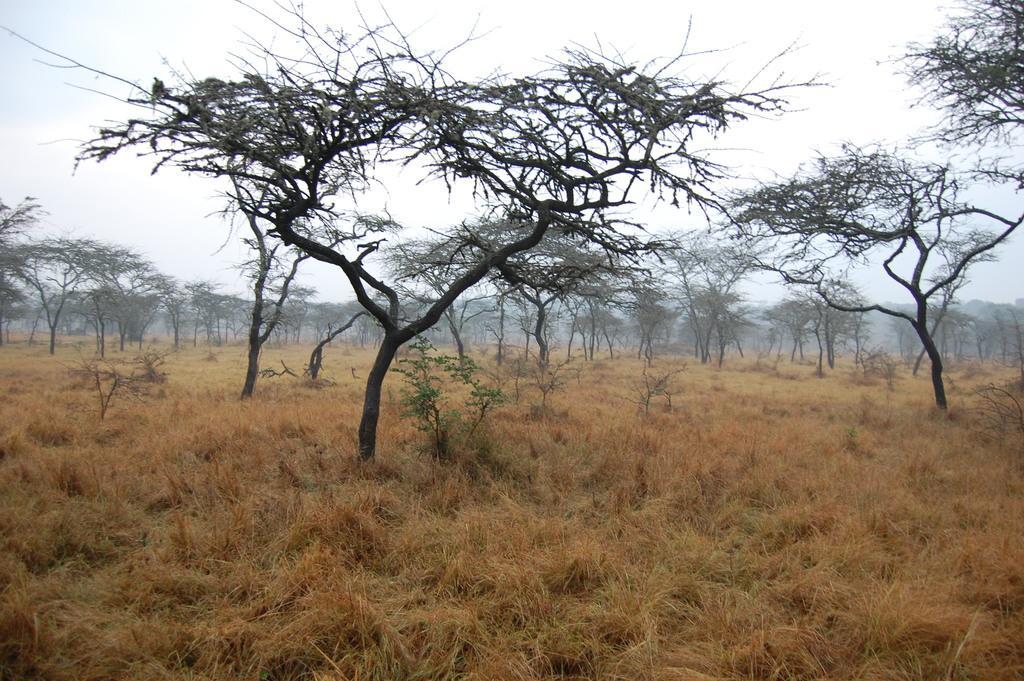How would you summarize this image in a sentence or two? In the picture there is grass, there are many trees present, there is a clear sky. 